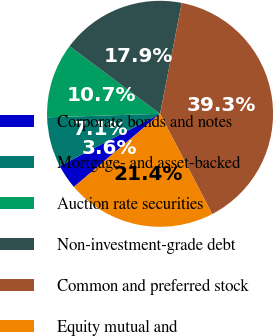Convert chart to OTSL. <chart><loc_0><loc_0><loc_500><loc_500><pie_chart><fcel>Corporate bonds and notes<fcel>Mortgage- and asset-backed<fcel>Auction rate securities<fcel>Non-investment-grade debt<fcel>Common and preferred stock<fcel>Equity mutual and<nl><fcel>3.57%<fcel>7.14%<fcel>10.71%<fcel>17.86%<fcel>39.29%<fcel>21.43%<nl></chart> 